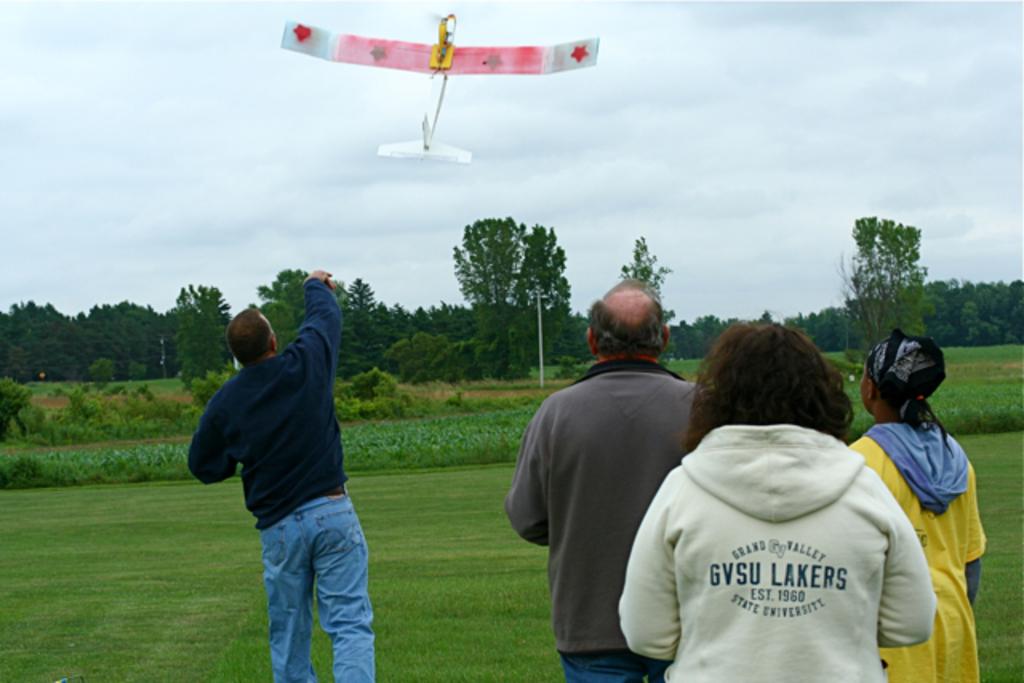What does her sweatshirt say?
Provide a short and direct response. Gvsu lakers. This man handle with aeroplane?
Provide a short and direct response. Yes. 